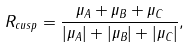<formula> <loc_0><loc_0><loc_500><loc_500>R _ { c u s p } = \frac { \mu _ { A } + \mu _ { B } + \mu _ { C } } { | \mu _ { A } | + | \mu _ { B } | + | \mu _ { C } | } ,</formula> 